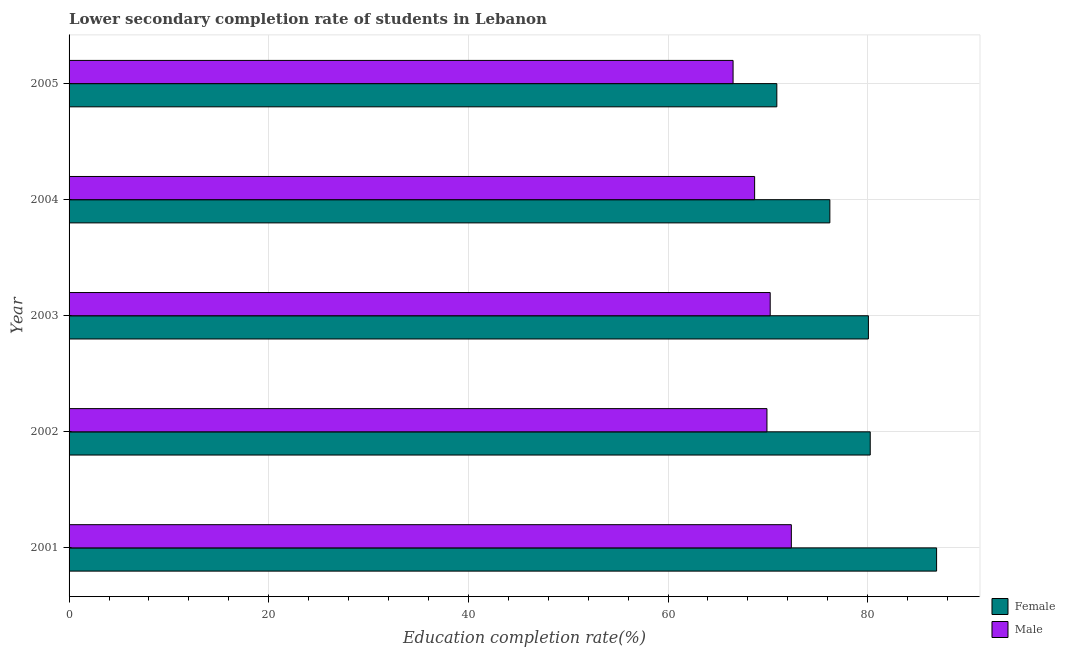How many different coloured bars are there?
Make the answer very short. 2. How many groups of bars are there?
Provide a succinct answer. 5. How many bars are there on the 4th tick from the top?
Your response must be concise. 2. In how many cases, is the number of bars for a given year not equal to the number of legend labels?
Provide a succinct answer. 0. What is the education completion rate of female students in 2004?
Provide a succinct answer. 76.21. Across all years, what is the maximum education completion rate of female students?
Give a very brief answer. 86.9. Across all years, what is the minimum education completion rate of male students?
Provide a short and direct response. 66.51. In which year was the education completion rate of female students maximum?
Keep it short and to the point. 2001. What is the total education completion rate of female students in the graph?
Provide a short and direct response. 394.33. What is the difference between the education completion rate of female students in 2003 and that in 2005?
Ensure brevity in your answer.  9.17. What is the difference between the education completion rate of male students in 2005 and the education completion rate of female students in 2002?
Give a very brief answer. -13.74. What is the average education completion rate of female students per year?
Provide a short and direct response. 78.86. In the year 2003, what is the difference between the education completion rate of female students and education completion rate of male students?
Offer a terse response. 9.84. What is the ratio of the education completion rate of male students in 2003 to that in 2005?
Your response must be concise. 1.06. Is the difference between the education completion rate of female students in 2003 and 2005 greater than the difference between the education completion rate of male students in 2003 and 2005?
Keep it short and to the point. Yes. What is the difference between the highest and the second highest education completion rate of male students?
Offer a terse response. 2.12. What is the difference between the highest and the lowest education completion rate of male students?
Give a very brief answer. 5.84. Is the sum of the education completion rate of female students in 2004 and 2005 greater than the maximum education completion rate of male students across all years?
Make the answer very short. Yes. What does the 1st bar from the top in 2004 represents?
Ensure brevity in your answer.  Male. What does the 2nd bar from the bottom in 2002 represents?
Ensure brevity in your answer.  Male. How many bars are there?
Provide a succinct answer. 10. How many years are there in the graph?
Ensure brevity in your answer.  5. What is the difference between two consecutive major ticks on the X-axis?
Ensure brevity in your answer.  20. Are the values on the major ticks of X-axis written in scientific E-notation?
Provide a succinct answer. No. Does the graph contain any zero values?
Your answer should be very brief. No. What is the title of the graph?
Give a very brief answer. Lower secondary completion rate of students in Lebanon. What is the label or title of the X-axis?
Make the answer very short. Education completion rate(%). What is the Education completion rate(%) of Female in 2001?
Provide a short and direct response. 86.9. What is the Education completion rate(%) of Male in 2001?
Make the answer very short. 72.35. What is the Education completion rate(%) of Female in 2002?
Offer a terse response. 80.25. What is the Education completion rate(%) in Male in 2002?
Your answer should be very brief. 69.91. What is the Education completion rate(%) in Female in 2003?
Your response must be concise. 80.07. What is the Education completion rate(%) of Male in 2003?
Your answer should be very brief. 70.23. What is the Education completion rate(%) in Female in 2004?
Your answer should be very brief. 76.21. What is the Education completion rate(%) in Male in 2004?
Offer a terse response. 68.67. What is the Education completion rate(%) in Female in 2005?
Keep it short and to the point. 70.9. What is the Education completion rate(%) of Male in 2005?
Offer a terse response. 66.51. Across all years, what is the maximum Education completion rate(%) of Female?
Offer a very short reply. 86.9. Across all years, what is the maximum Education completion rate(%) of Male?
Provide a short and direct response. 72.35. Across all years, what is the minimum Education completion rate(%) in Female?
Your answer should be compact. 70.9. Across all years, what is the minimum Education completion rate(%) in Male?
Your response must be concise. 66.51. What is the total Education completion rate(%) in Female in the graph?
Your answer should be very brief. 394.33. What is the total Education completion rate(%) in Male in the graph?
Your response must be concise. 347.68. What is the difference between the Education completion rate(%) of Female in 2001 and that in 2002?
Keep it short and to the point. 6.65. What is the difference between the Education completion rate(%) in Male in 2001 and that in 2002?
Offer a very short reply. 2.44. What is the difference between the Education completion rate(%) in Female in 2001 and that in 2003?
Make the answer very short. 6.83. What is the difference between the Education completion rate(%) of Male in 2001 and that in 2003?
Ensure brevity in your answer.  2.12. What is the difference between the Education completion rate(%) in Female in 2001 and that in 2004?
Ensure brevity in your answer.  10.69. What is the difference between the Education completion rate(%) of Male in 2001 and that in 2004?
Your response must be concise. 3.68. What is the difference between the Education completion rate(%) of Female in 2001 and that in 2005?
Your answer should be very brief. 16. What is the difference between the Education completion rate(%) in Male in 2001 and that in 2005?
Ensure brevity in your answer.  5.84. What is the difference between the Education completion rate(%) in Female in 2002 and that in 2003?
Provide a short and direct response. 0.18. What is the difference between the Education completion rate(%) of Male in 2002 and that in 2003?
Your answer should be very brief. -0.32. What is the difference between the Education completion rate(%) in Female in 2002 and that in 2004?
Offer a terse response. 4.04. What is the difference between the Education completion rate(%) of Male in 2002 and that in 2004?
Your answer should be very brief. 1.23. What is the difference between the Education completion rate(%) in Female in 2002 and that in 2005?
Your answer should be very brief. 9.36. What is the difference between the Education completion rate(%) in Male in 2002 and that in 2005?
Offer a terse response. 3.39. What is the difference between the Education completion rate(%) in Female in 2003 and that in 2004?
Give a very brief answer. 3.86. What is the difference between the Education completion rate(%) in Male in 2003 and that in 2004?
Give a very brief answer. 1.56. What is the difference between the Education completion rate(%) of Female in 2003 and that in 2005?
Your answer should be compact. 9.17. What is the difference between the Education completion rate(%) in Male in 2003 and that in 2005?
Provide a short and direct response. 3.72. What is the difference between the Education completion rate(%) of Female in 2004 and that in 2005?
Your answer should be compact. 5.31. What is the difference between the Education completion rate(%) in Male in 2004 and that in 2005?
Offer a terse response. 2.16. What is the difference between the Education completion rate(%) of Female in 2001 and the Education completion rate(%) of Male in 2002?
Your answer should be compact. 16.99. What is the difference between the Education completion rate(%) in Female in 2001 and the Education completion rate(%) in Male in 2003?
Keep it short and to the point. 16.67. What is the difference between the Education completion rate(%) in Female in 2001 and the Education completion rate(%) in Male in 2004?
Your answer should be compact. 18.23. What is the difference between the Education completion rate(%) of Female in 2001 and the Education completion rate(%) of Male in 2005?
Keep it short and to the point. 20.39. What is the difference between the Education completion rate(%) in Female in 2002 and the Education completion rate(%) in Male in 2003?
Your response must be concise. 10.02. What is the difference between the Education completion rate(%) in Female in 2002 and the Education completion rate(%) in Male in 2004?
Offer a terse response. 11.58. What is the difference between the Education completion rate(%) of Female in 2002 and the Education completion rate(%) of Male in 2005?
Provide a succinct answer. 13.74. What is the difference between the Education completion rate(%) of Female in 2003 and the Education completion rate(%) of Male in 2004?
Make the answer very short. 11.4. What is the difference between the Education completion rate(%) of Female in 2003 and the Education completion rate(%) of Male in 2005?
Offer a terse response. 13.56. What is the difference between the Education completion rate(%) in Female in 2004 and the Education completion rate(%) in Male in 2005?
Offer a terse response. 9.69. What is the average Education completion rate(%) of Female per year?
Give a very brief answer. 78.87. What is the average Education completion rate(%) in Male per year?
Provide a succinct answer. 69.53. In the year 2001, what is the difference between the Education completion rate(%) in Female and Education completion rate(%) in Male?
Give a very brief answer. 14.55. In the year 2002, what is the difference between the Education completion rate(%) in Female and Education completion rate(%) in Male?
Make the answer very short. 10.34. In the year 2003, what is the difference between the Education completion rate(%) in Female and Education completion rate(%) in Male?
Ensure brevity in your answer.  9.84. In the year 2004, what is the difference between the Education completion rate(%) of Female and Education completion rate(%) of Male?
Your answer should be compact. 7.53. In the year 2005, what is the difference between the Education completion rate(%) in Female and Education completion rate(%) in Male?
Your response must be concise. 4.38. What is the ratio of the Education completion rate(%) of Female in 2001 to that in 2002?
Offer a terse response. 1.08. What is the ratio of the Education completion rate(%) of Male in 2001 to that in 2002?
Give a very brief answer. 1.03. What is the ratio of the Education completion rate(%) in Female in 2001 to that in 2003?
Make the answer very short. 1.09. What is the ratio of the Education completion rate(%) of Male in 2001 to that in 2003?
Make the answer very short. 1.03. What is the ratio of the Education completion rate(%) of Female in 2001 to that in 2004?
Your response must be concise. 1.14. What is the ratio of the Education completion rate(%) in Male in 2001 to that in 2004?
Ensure brevity in your answer.  1.05. What is the ratio of the Education completion rate(%) in Female in 2001 to that in 2005?
Your answer should be compact. 1.23. What is the ratio of the Education completion rate(%) in Male in 2001 to that in 2005?
Your response must be concise. 1.09. What is the ratio of the Education completion rate(%) in Male in 2002 to that in 2003?
Offer a very short reply. 1. What is the ratio of the Education completion rate(%) of Female in 2002 to that in 2004?
Ensure brevity in your answer.  1.05. What is the ratio of the Education completion rate(%) of Male in 2002 to that in 2004?
Offer a very short reply. 1.02. What is the ratio of the Education completion rate(%) of Female in 2002 to that in 2005?
Make the answer very short. 1.13. What is the ratio of the Education completion rate(%) of Male in 2002 to that in 2005?
Make the answer very short. 1.05. What is the ratio of the Education completion rate(%) of Female in 2003 to that in 2004?
Offer a terse response. 1.05. What is the ratio of the Education completion rate(%) in Male in 2003 to that in 2004?
Provide a succinct answer. 1.02. What is the ratio of the Education completion rate(%) in Female in 2003 to that in 2005?
Offer a very short reply. 1.13. What is the ratio of the Education completion rate(%) of Male in 2003 to that in 2005?
Your answer should be very brief. 1.06. What is the ratio of the Education completion rate(%) of Female in 2004 to that in 2005?
Offer a very short reply. 1.07. What is the ratio of the Education completion rate(%) of Male in 2004 to that in 2005?
Offer a very short reply. 1.03. What is the difference between the highest and the second highest Education completion rate(%) in Female?
Provide a succinct answer. 6.65. What is the difference between the highest and the second highest Education completion rate(%) in Male?
Ensure brevity in your answer.  2.12. What is the difference between the highest and the lowest Education completion rate(%) of Female?
Your answer should be very brief. 16. What is the difference between the highest and the lowest Education completion rate(%) in Male?
Offer a terse response. 5.84. 